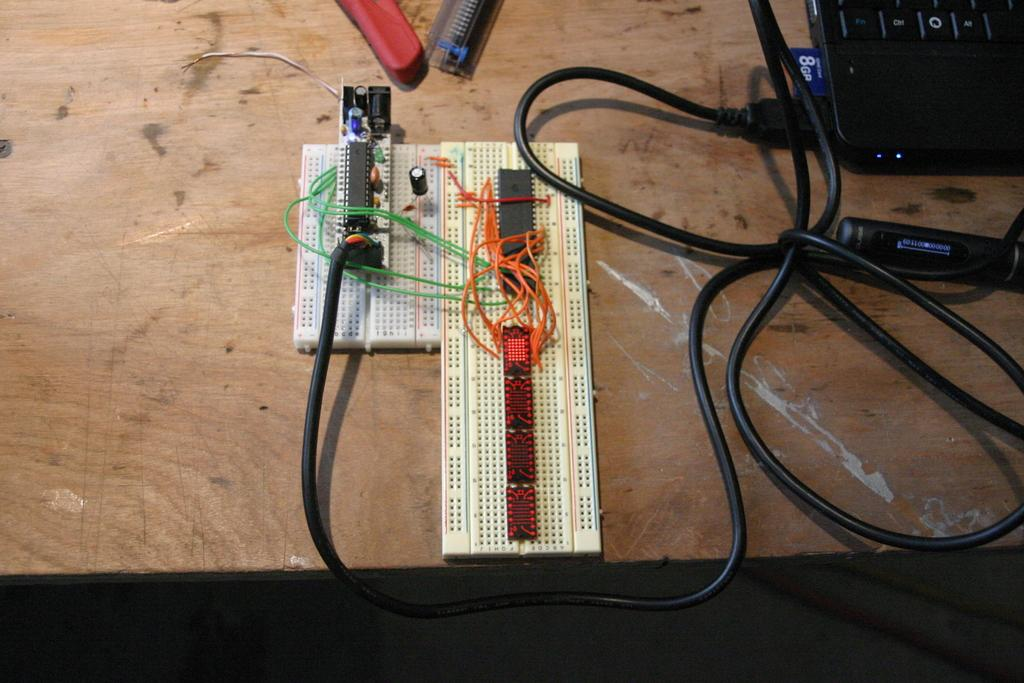What is the main object in the center of the image? There is a bread board in the center of the image. What type of materials can be seen in the image? Wires and cables are visible in the image. What electronic device is present in the image? There is a laptop in the image. What is the surface that the laptop and other objects are placed on? There is a wooden object that seems to be a table in the image. What other objects are placed on the table? Other objects are placed on the table, but their specific details are not mentioned in the facts. What type of drain is visible in the image? There is no drain present in the image. What type of pan is being used to cook on the bread board? There is no pan or cooking activity visible in the image. 